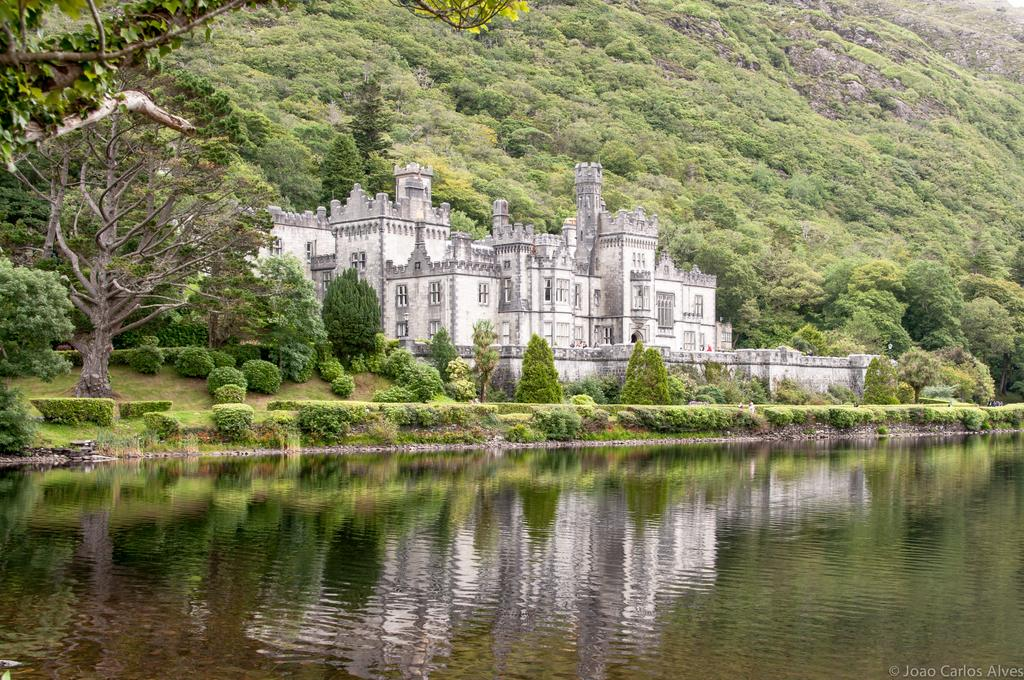What type of structure is present in the image? There is a building in the image. What feature can be seen on the building? The building has windows. What type of vegetation is visible in the image? There are trees, plants, and grass in the image. What natural element is visible at the bottom of the image? There is water visible at the bottom of the image. What geographical feature can be seen at the top of the image? There is a hill visible at the top of the image. What type of hands can be seen holding a liquid on a shelf in the image? There are no hands, liquid, or shelf present in the image. 